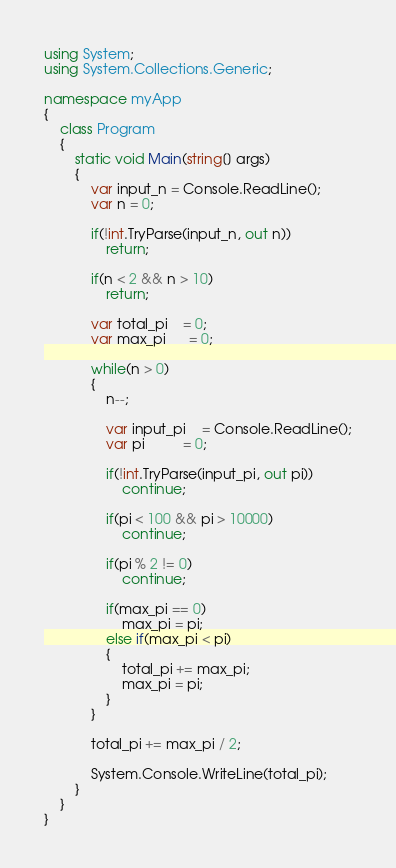Convert code to text. <code><loc_0><loc_0><loc_500><loc_500><_C#_>using System;
using System.Collections.Generic;

namespace myApp
{
    class Program
    {
        static void Main(string[] args)
        {
            var input_n = Console.ReadLine();
            var n = 0;

            if(!int.TryParse(input_n, out n))
                return;

            if(n < 2 && n > 10)
                return;

            var total_pi    = 0;
            var max_pi      = 0;

            while(n > 0)
            {
                n--;

                var input_pi    = Console.ReadLine();
                var pi          = 0;

                if(!int.TryParse(input_pi, out pi))
                    continue;

                if(pi < 100 && pi > 10000)
                    continue;

                if(pi % 2 != 0)
                    continue;

                if(max_pi == 0)
                    max_pi = pi;
                else if(max_pi < pi)
                {
                    total_pi += max_pi;
                    max_pi = pi;
                }
            }

            total_pi += max_pi / 2;

            System.Console.WriteLine(total_pi);
        }
    }
}
</code> 